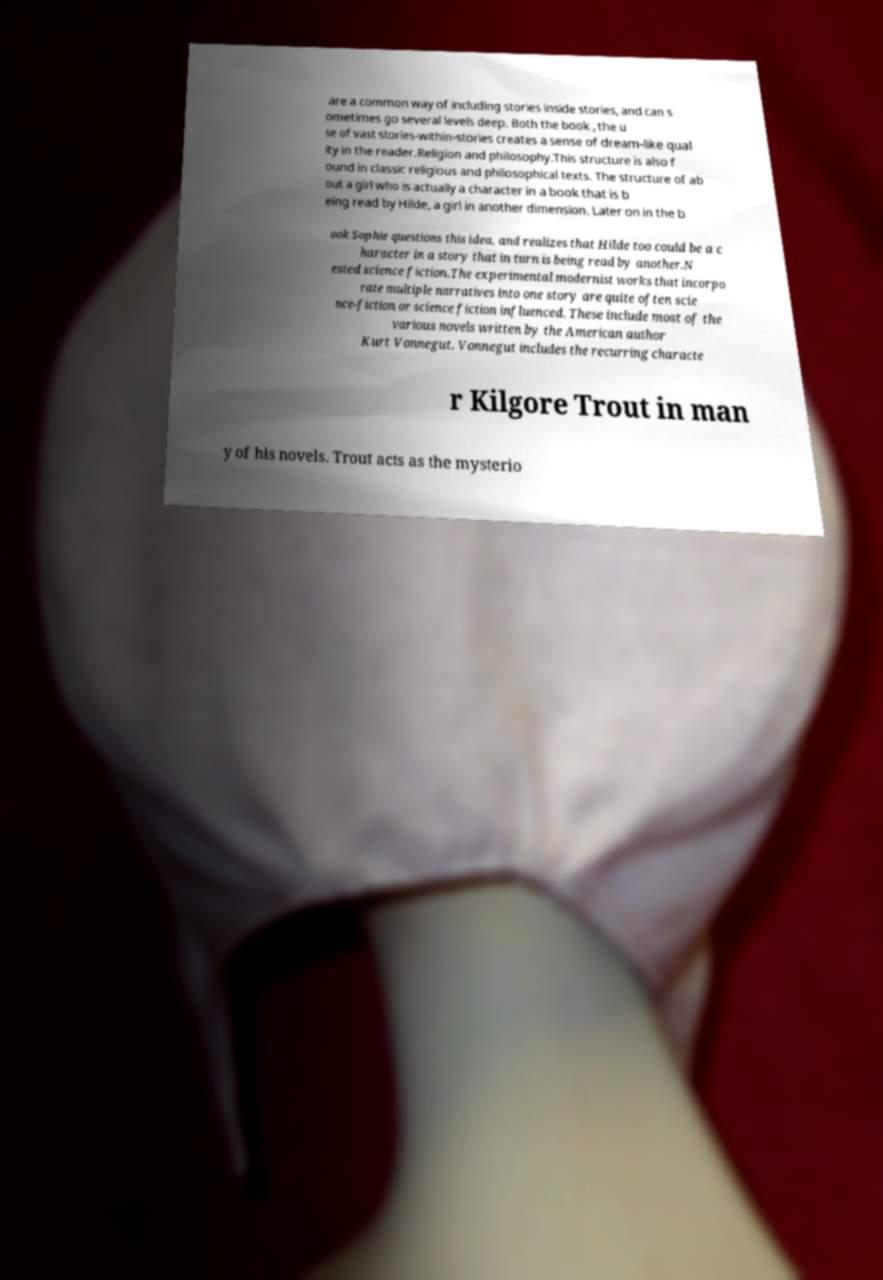I need the written content from this picture converted into text. Can you do that? are a common way of including stories inside stories, and can s ometimes go several levels deep. Both the book , the u se of vast stories-within-stories creates a sense of dream-like qual ity in the reader.Religion and philosophy.This structure is also f ound in classic religious and philosophical texts. The structure of ab out a girl who is actually a character in a book that is b eing read by Hilde, a girl in another dimension. Later on in the b ook Sophie questions this idea, and realizes that Hilde too could be a c haracter in a story that in turn is being read by another.N ested science fiction.The experimental modernist works that incorpo rate multiple narratives into one story are quite often scie nce-fiction or science fiction influenced. These include most of the various novels written by the American author Kurt Vonnegut. Vonnegut includes the recurring characte r Kilgore Trout in man y of his novels. Trout acts as the mysterio 